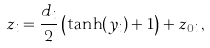Convert formula to latex. <formula><loc_0><loc_0><loc_500><loc_500>z _ { i } = \frac { d _ { i } } { 2 } \left ( \tanh ( y _ { i } ) + 1 \right ) + z _ { 0 i } \, ,</formula> 